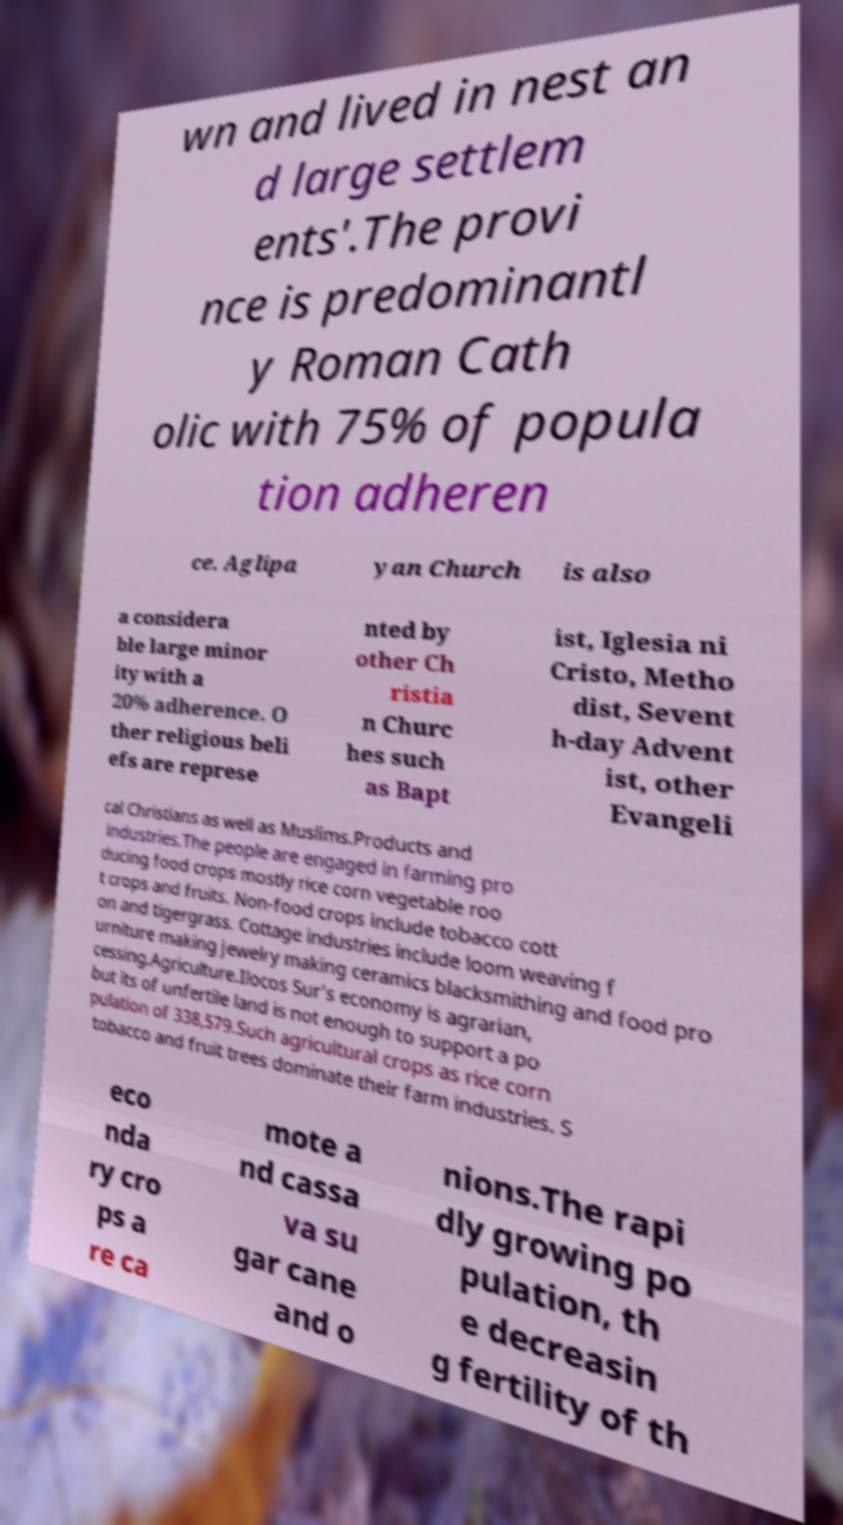What messages or text are displayed in this image? I need them in a readable, typed format. wn and lived in nest an d large settlem ents'.The provi nce is predominantl y Roman Cath olic with 75% of popula tion adheren ce. Aglipa yan Church is also a considera ble large minor ity with a 20% adherence. O ther religious beli efs are represe nted by other Ch ristia n Churc hes such as Bapt ist, Iglesia ni Cristo, Metho dist, Sevent h-day Advent ist, other Evangeli cal Christians as well as Muslims.Products and industries.The people are engaged in farming pro ducing food crops mostly rice corn vegetable roo t crops and fruits. Non-food crops include tobacco cott on and tigergrass. Cottage industries include loom weaving f urniture making jewelry making ceramics blacksmithing and food pro cessing.Agriculture.Ilocos Sur's economy is agrarian, but its of unfertile land is not enough to support a po pulation of 338,579.Such agricultural crops as rice corn tobacco and fruit trees dominate their farm industries. S eco nda ry cro ps a re ca mote a nd cassa va su gar cane and o nions.The rapi dly growing po pulation, th e decreasin g fertility of th 